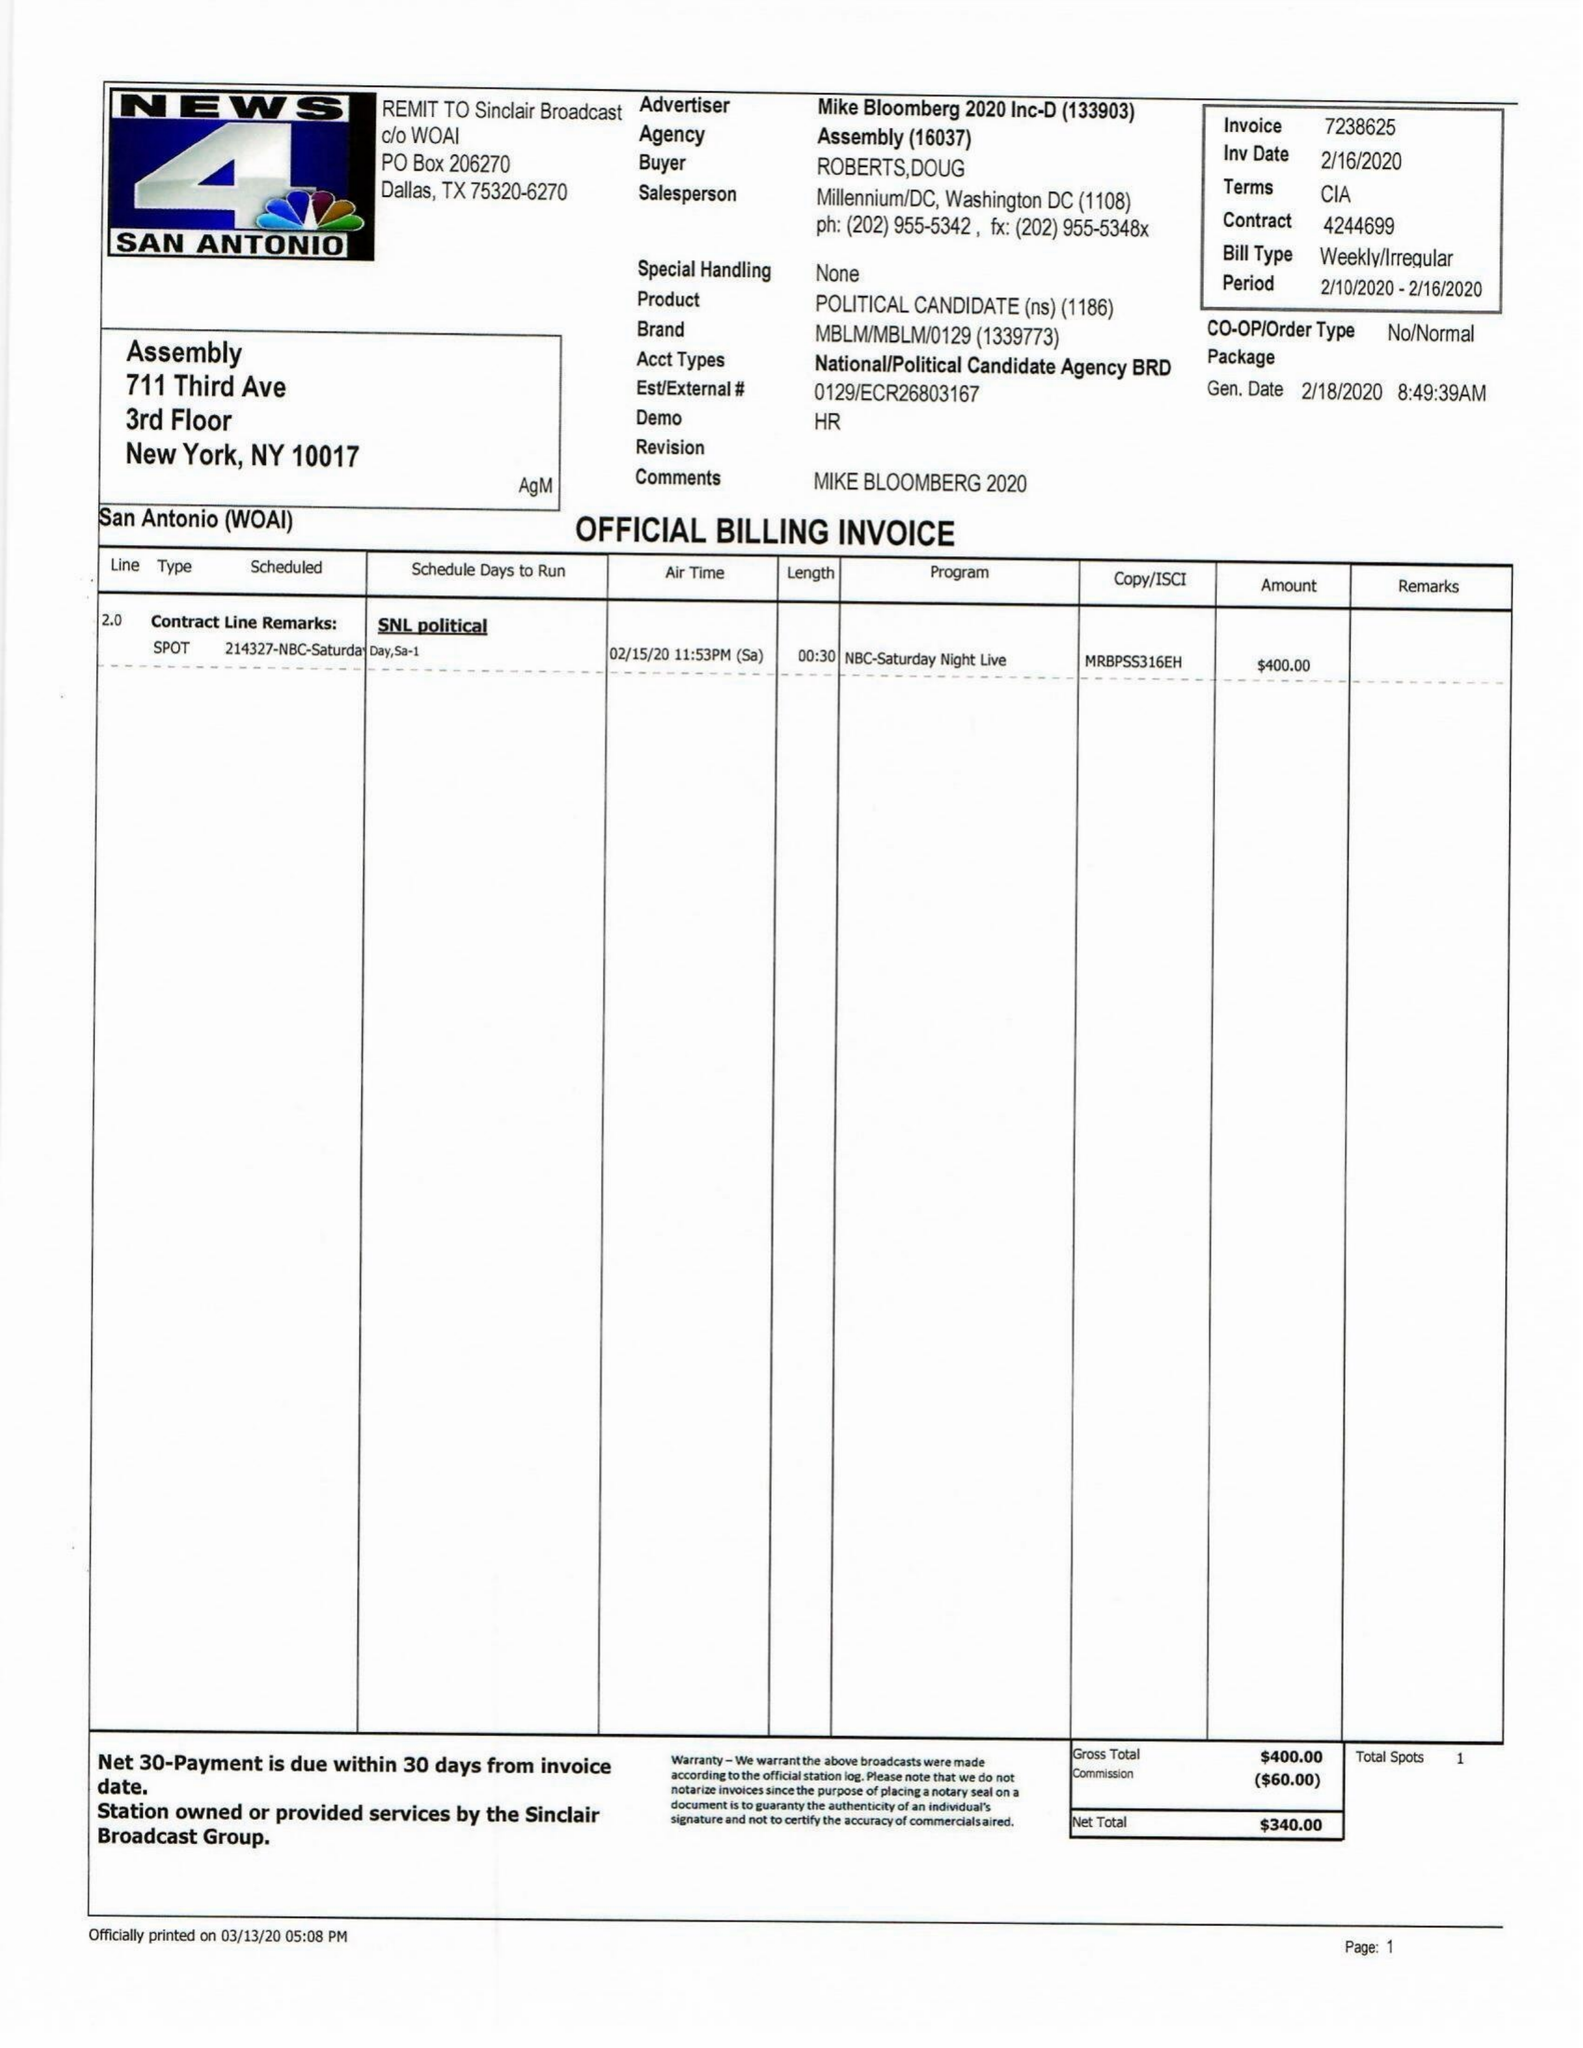What is the value for the contract_num?
Answer the question using a single word or phrase. 4244699 